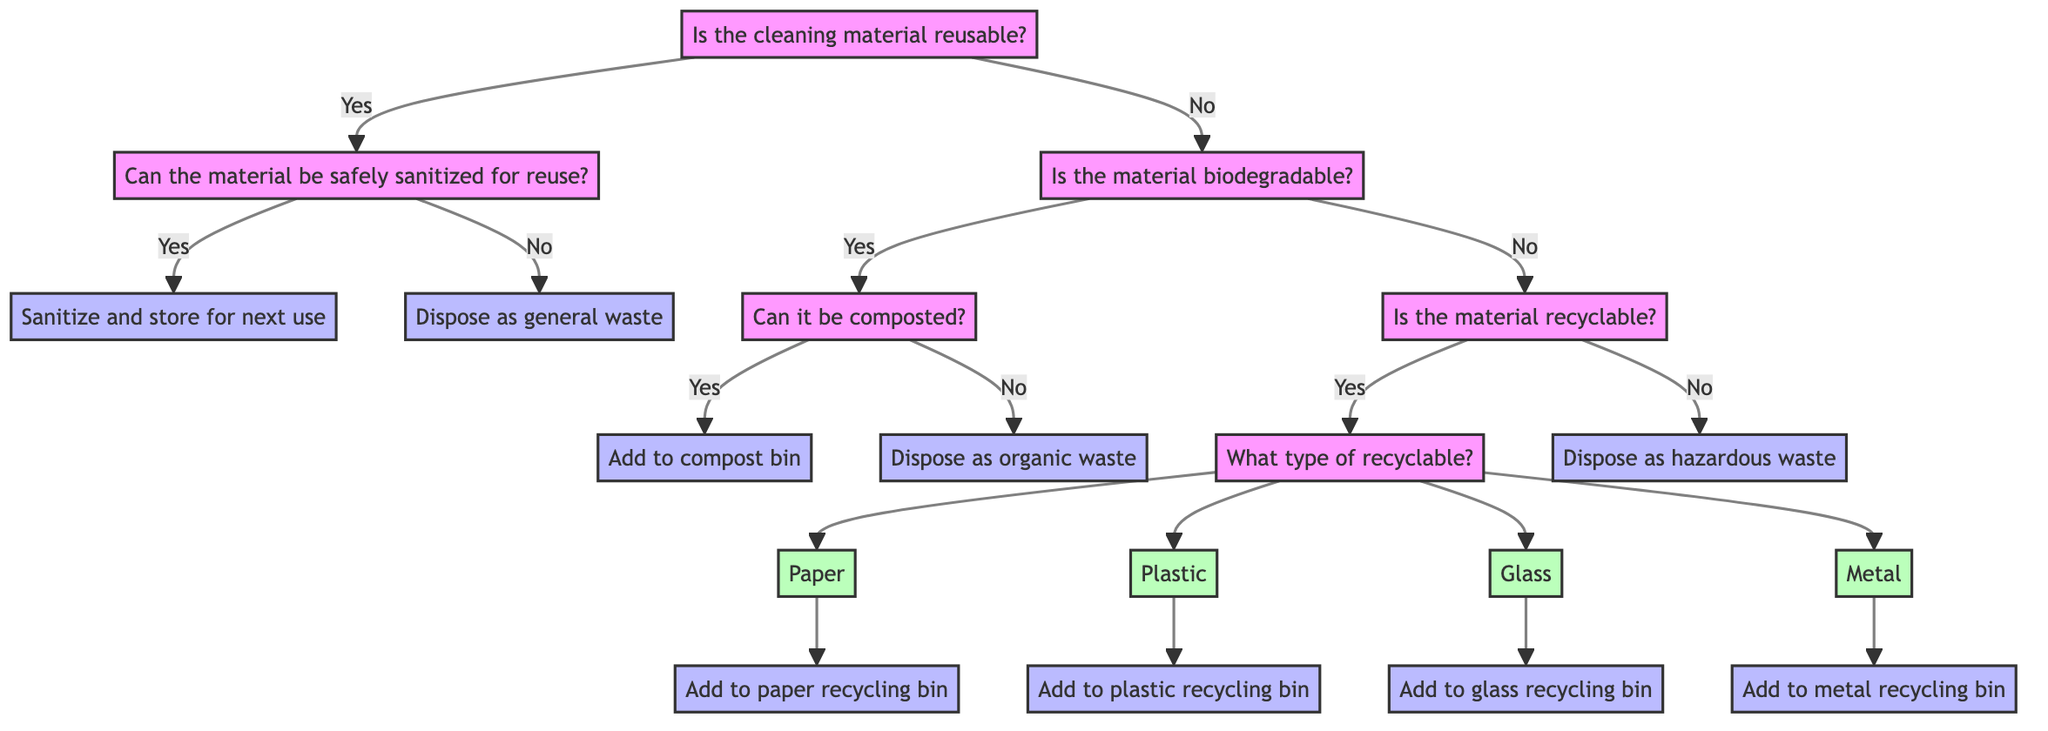Is the starting point of the decision tree about cleaning material disposal? The starting point of the decision tree is a question regarding whether the cleaning material is reusable or not. This is the initial decision that leads to different pathways based on the responses.
Answer: Yes What action is taken if the cleaning material is reusable but cannot be safely sanitized? If the cleaning material is reusable but cannot be safely sanitized, the action taken is to dispose of it as general waste. This follows the yes-no pathway from the initial question about reusability.
Answer: Dispose as general waste How many types of recyclable materials are mentioned in the diagram? The diagram mentions four types of recyclable materials: paper, plastic, glass, and metal. These materials are identified in question nodes that ask about the type of recyclable material to be disposed of properly.
Answer: Four What should be done with cleaning materials that are biodegradable but cannot be composted? If the cleaning material is biodegradable but cannot be composted, the action is to dispose of it as organic waste. This is determined by the flow through the biodegradable question and subsequent pathways in the decision tree.
Answer: Dispose as organic waste What do you do if the cleaning material is not reusable, biodegradable, or recyclable? If the cleaning material falls into none of these categories, it should be disposed of as hazardous waste. This conclusion follows the multiple-pathway reasoning of the decision tree starting from the initial question.
Answer: Dispose as hazardous waste What action corresponds to paper as a recyclable material? The action corresponding to paper when identified as a recyclable material is to add it to the paper recycling bin. This is a direct action step associated with the recyclable type identified.
Answer: Add to paper recycling bin Is there a decision made about composting after establishing the material is biodegradable? Yes, there is a decision made about composting after determining the material is biodegradable. The decision tree specifically asks if it can be composted, leading to different actions based on the answer.
Answer: Yes What is the outcome if the cleaning material is recyclable but not one of the listed types? If the cleaning material is recyclable but not one of the listed types (paper, plastic, glass, or metal), the diagram does not specify an action, implying that the material would fall into a category not covered, potentially leading to a need for clarification.
Answer: Not specified 